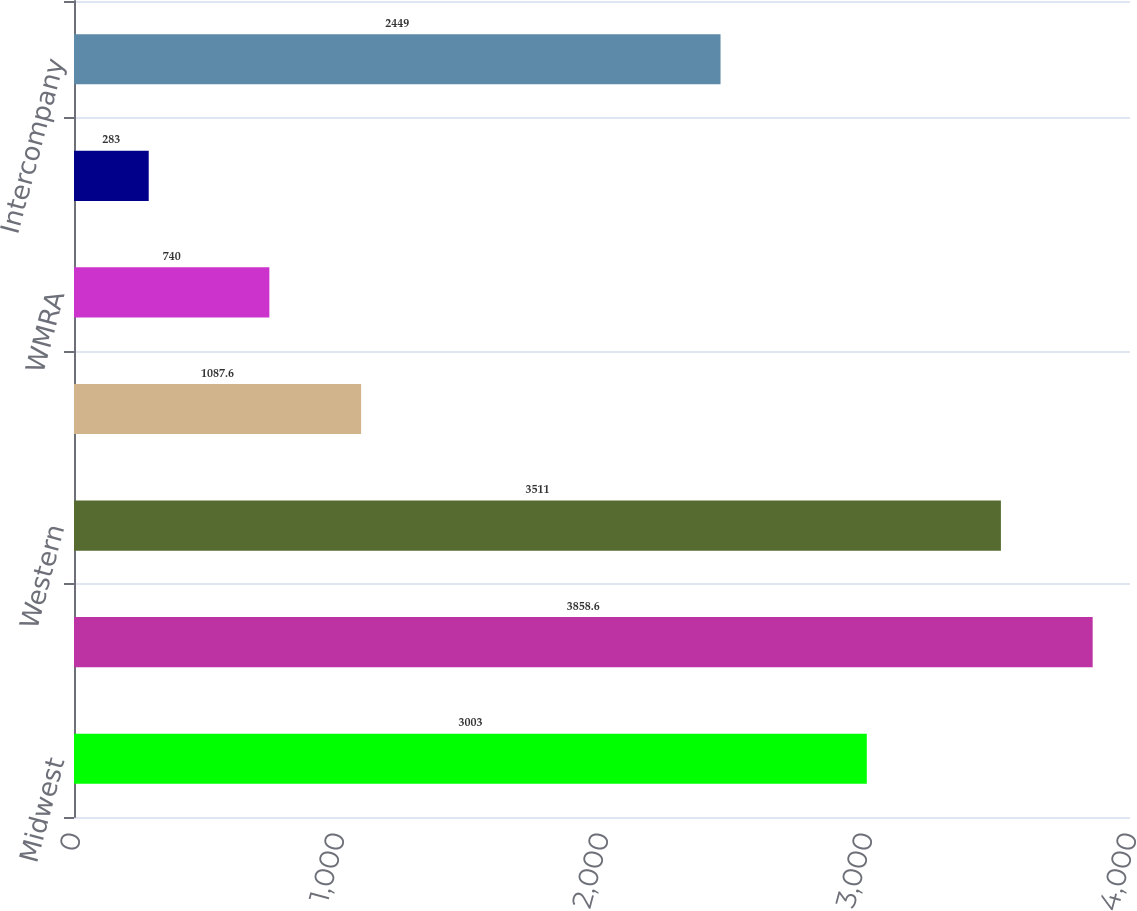Convert chart. <chart><loc_0><loc_0><loc_500><loc_500><bar_chart><fcel>Midwest<fcel>Southern<fcel>Western<fcel>Wheelabrator<fcel>WMRA<fcel>Other<fcel>Intercompany<nl><fcel>3003<fcel>3858.6<fcel>3511<fcel>1087.6<fcel>740<fcel>283<fcel>2449<nl></chart> 